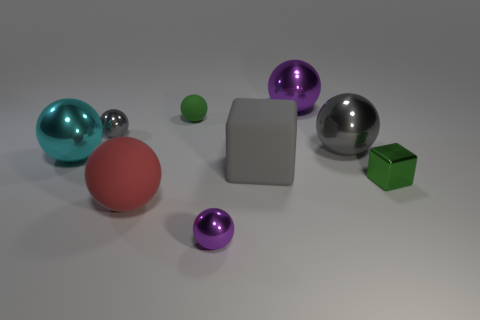There is another tiny thing that is the same color as the tiny rubber object; what is its shape?
Offer a very short reply. Cube. Are there any large matte things?
Provide a succinct answer. Yes. Is the shape of the purple metal thing in front of the red rubber ball the same as the rubber object that is right of the tiny purple metallic sphere?
Keep it short and to the point. No. What number of big objects are either purple cylinders or gray things?
Keep it short and to the point. 2. There is a tiny object that is made of the same material as the large red thing; what shape is it?
Offer a terse response. Sphere. Is the big red object the same shape as the large gray shiny thing?
Ensure brevity in your answer.  Yes. The tiny rubber sphere has what color?
Make the answer very short. Green. What number of things are gray rubber blocks or cyan spheres?
Ensure brevity in your answer.  2. Is the number of large rubber spheres behind the tiny gray metal object less than the number of big rubber things?
Give a very brief answer. Yes. Is the number of large things that are in front of the gray rubber block greater than the number of blocks right of the tiny green shiny object?
Your answer should be compact. Yes. 